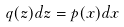Convert formula to latex. <formula><loc_0><loc_0><loc_500><loc_500>q ( z ) d z = p ( x ) d x</formula> 